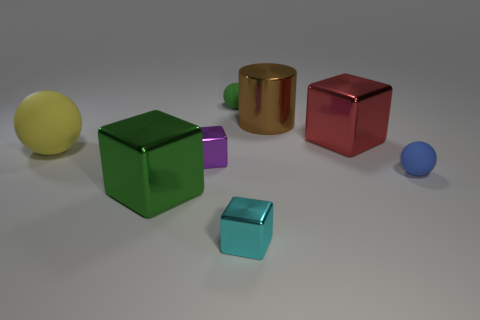Add 1 rubber balls. How many objects exist? 9 Subtract all cylinders. How many objects are left? 7 Subtract 0 cyan balls. How many objects are left? 8 Subtract all cylinders. Subtract all small cyan metallic objects. How many objects are left? 6 Add 8 brown cylinders. How many brown cylinders are left? 9 Add 3 blue things. How many blue things exist? 4 